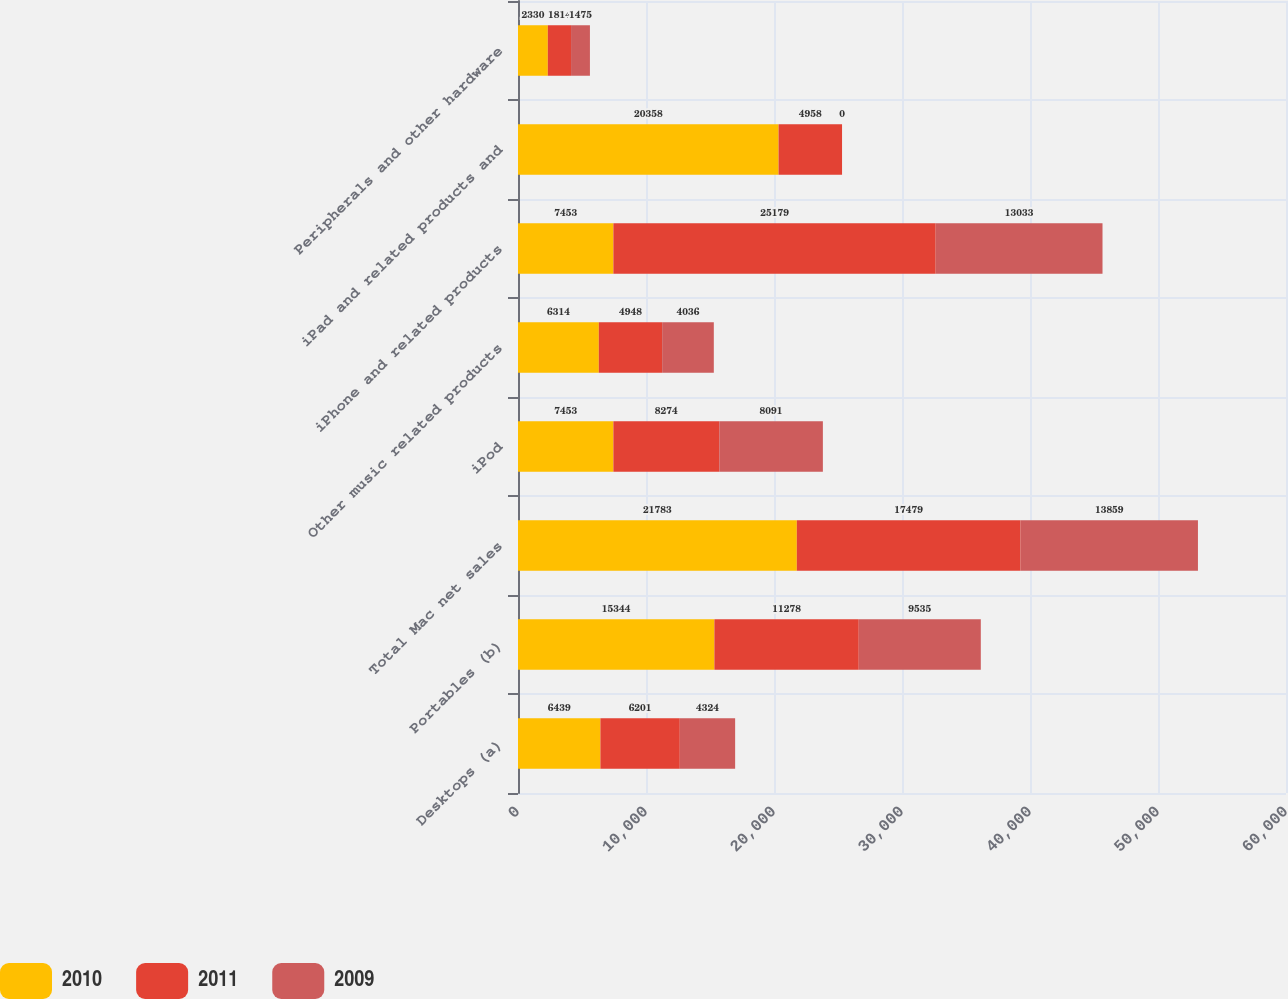<chart> <loc_0><loc_0><loc_500><loc_500><stacked_bar_chart><ecel><fcel>Desktops (a)<fcel>Portables (b)<fcel>Total Mac net sales<fcel>iPod<fcel>Other music related products<fcel>iPhone and related products<fcel>iPad and related products and<fcel>Peripherals and other hardware<nl><fcel>2010<fcel>6439<fcel>15344<fcel>21783<fcel>7453<fcel>6314<fcel>7453<fcel>20358<fcel>2330<nl><fcel>2011<fcel>6201<fcel>11278<fcel>17479<fcel>8274<fcel>4948<fcel>25179<fcel>4958<fcel>1814<nl><fcel>2009<fcel>4324<fcel>9535<fcel>13859<fcel>8091<fcel>4036<fcel>13033<fcel>0<fcel>1475<nl></chart> 